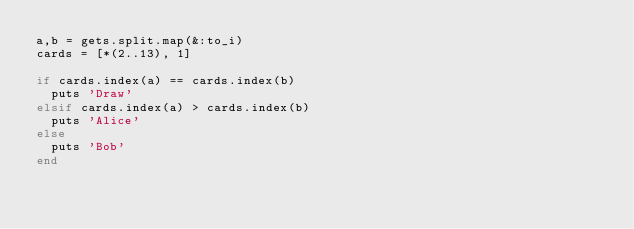Convert code to text. <code><loc_0><loc_0><loc_500><loc_500><_Ruby_>a,b = gets.split.map(&:to_i)
cards = [*(2..13), 1]

if cards.index(a) == cards.index(b)
  puts 'Draw'
elsif cards.index(a) > cards.index(b)
  puts 'Alice'
else
  puts 'Bob'
end</code> 